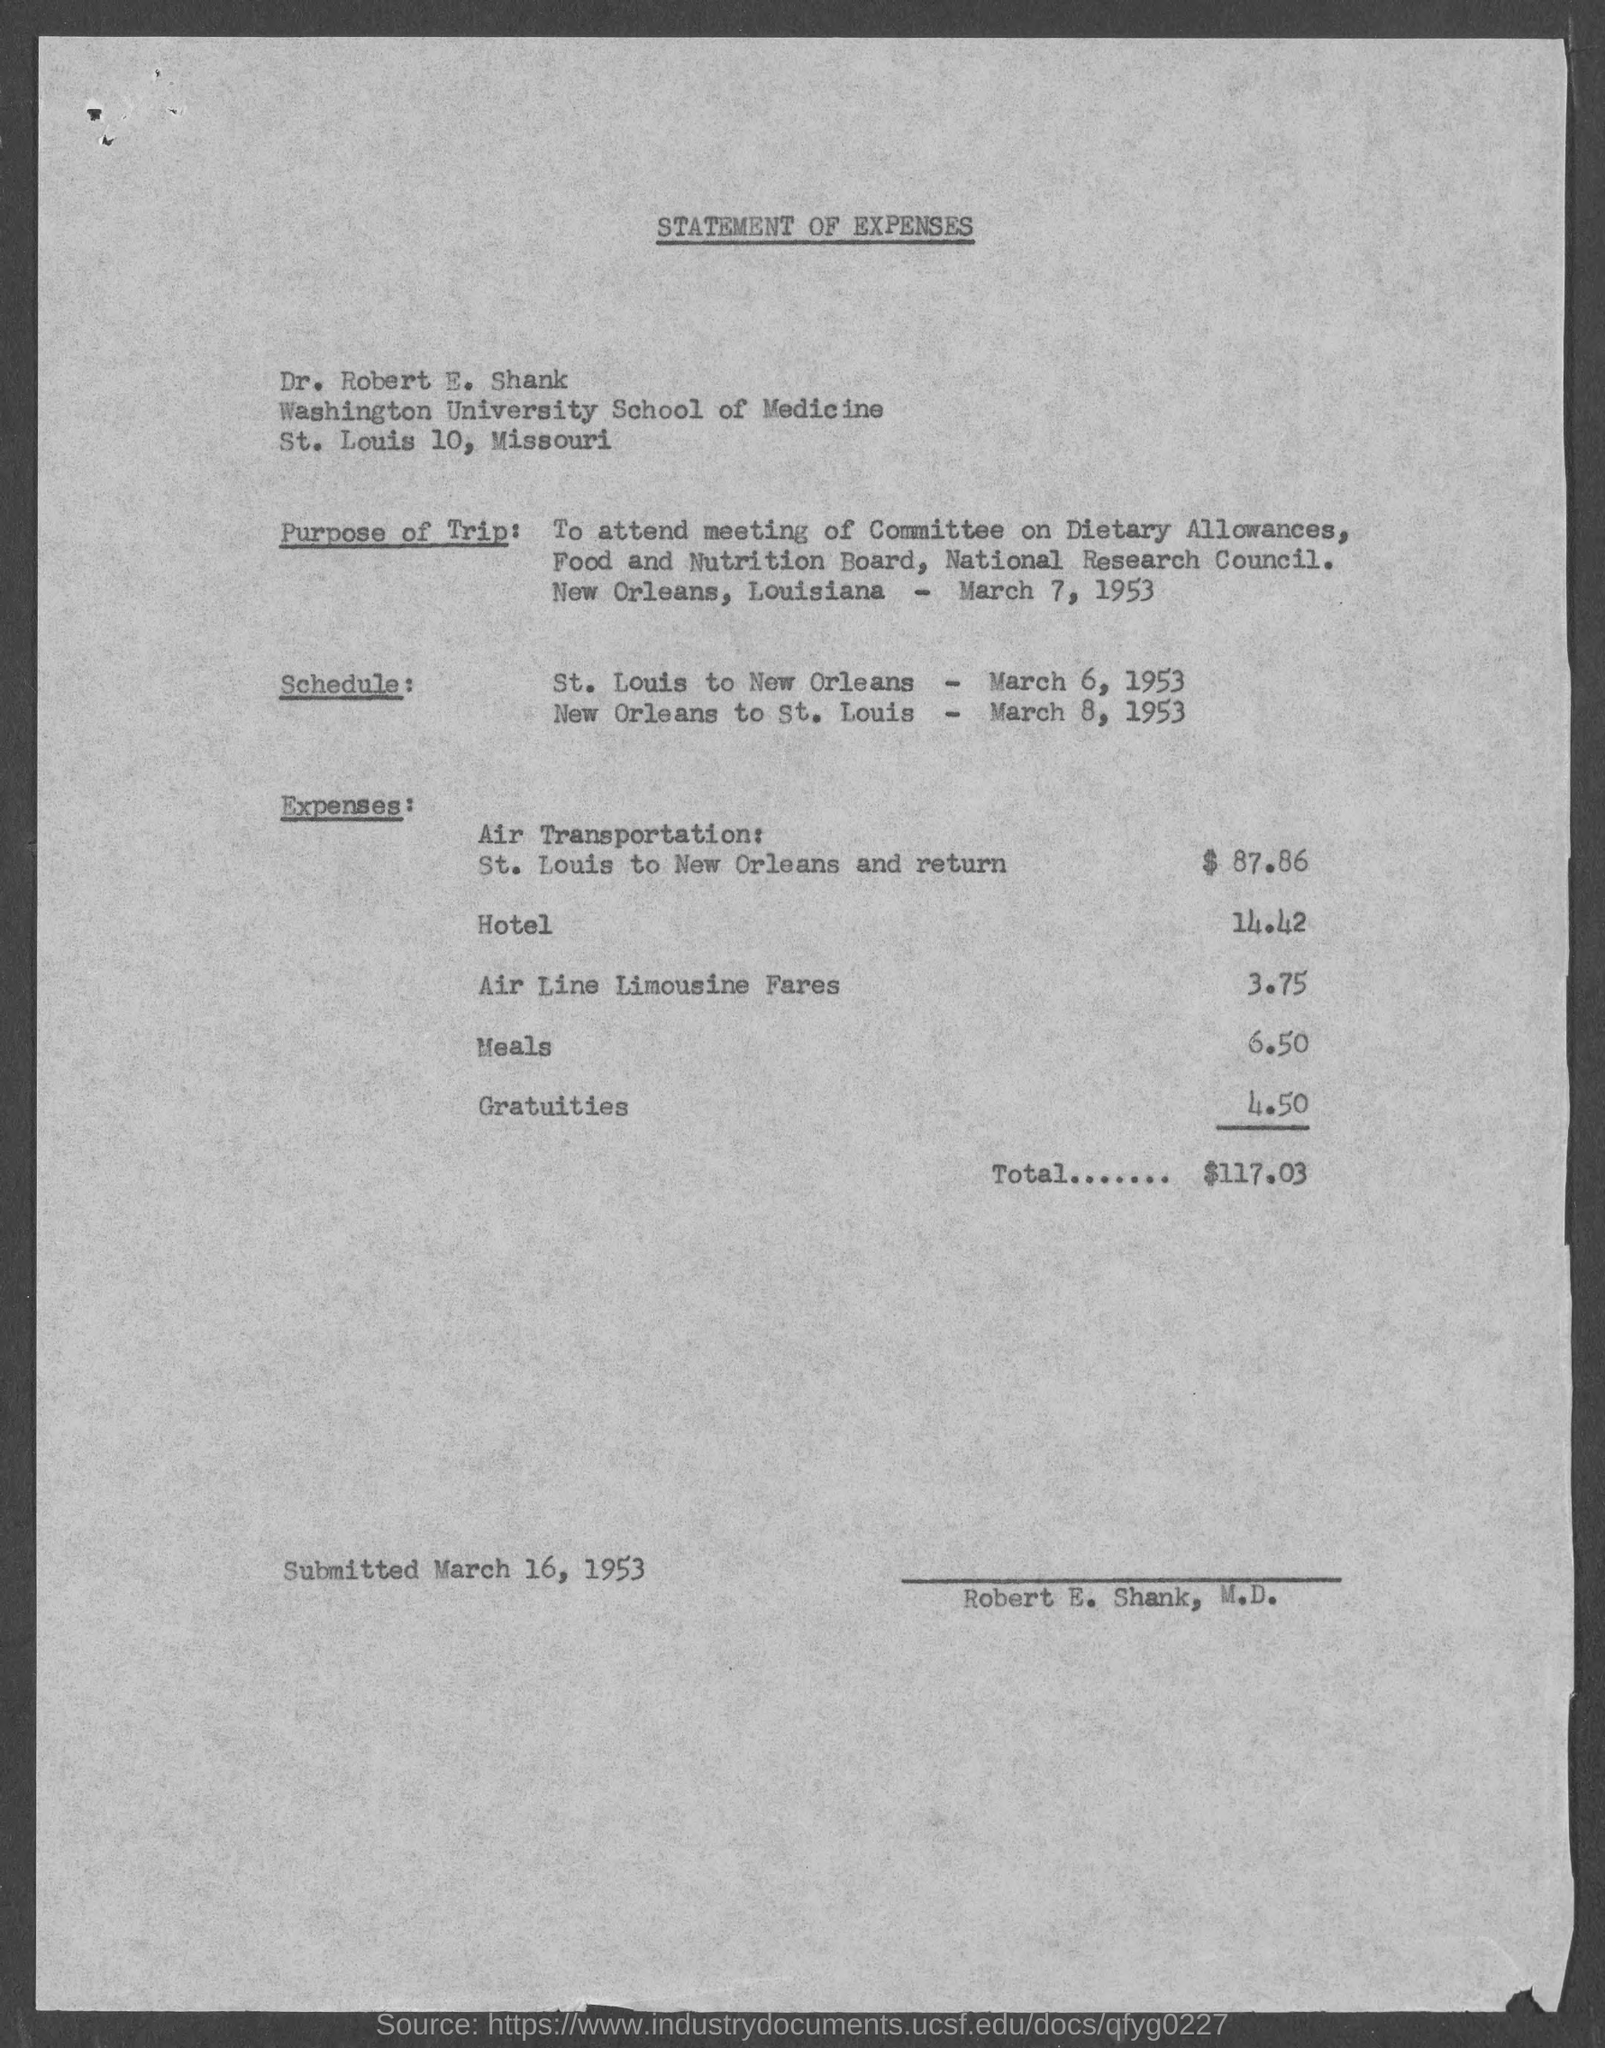Specify some key components in this picture. The date mentioned in the bottom of the document is March 16, 1953. 